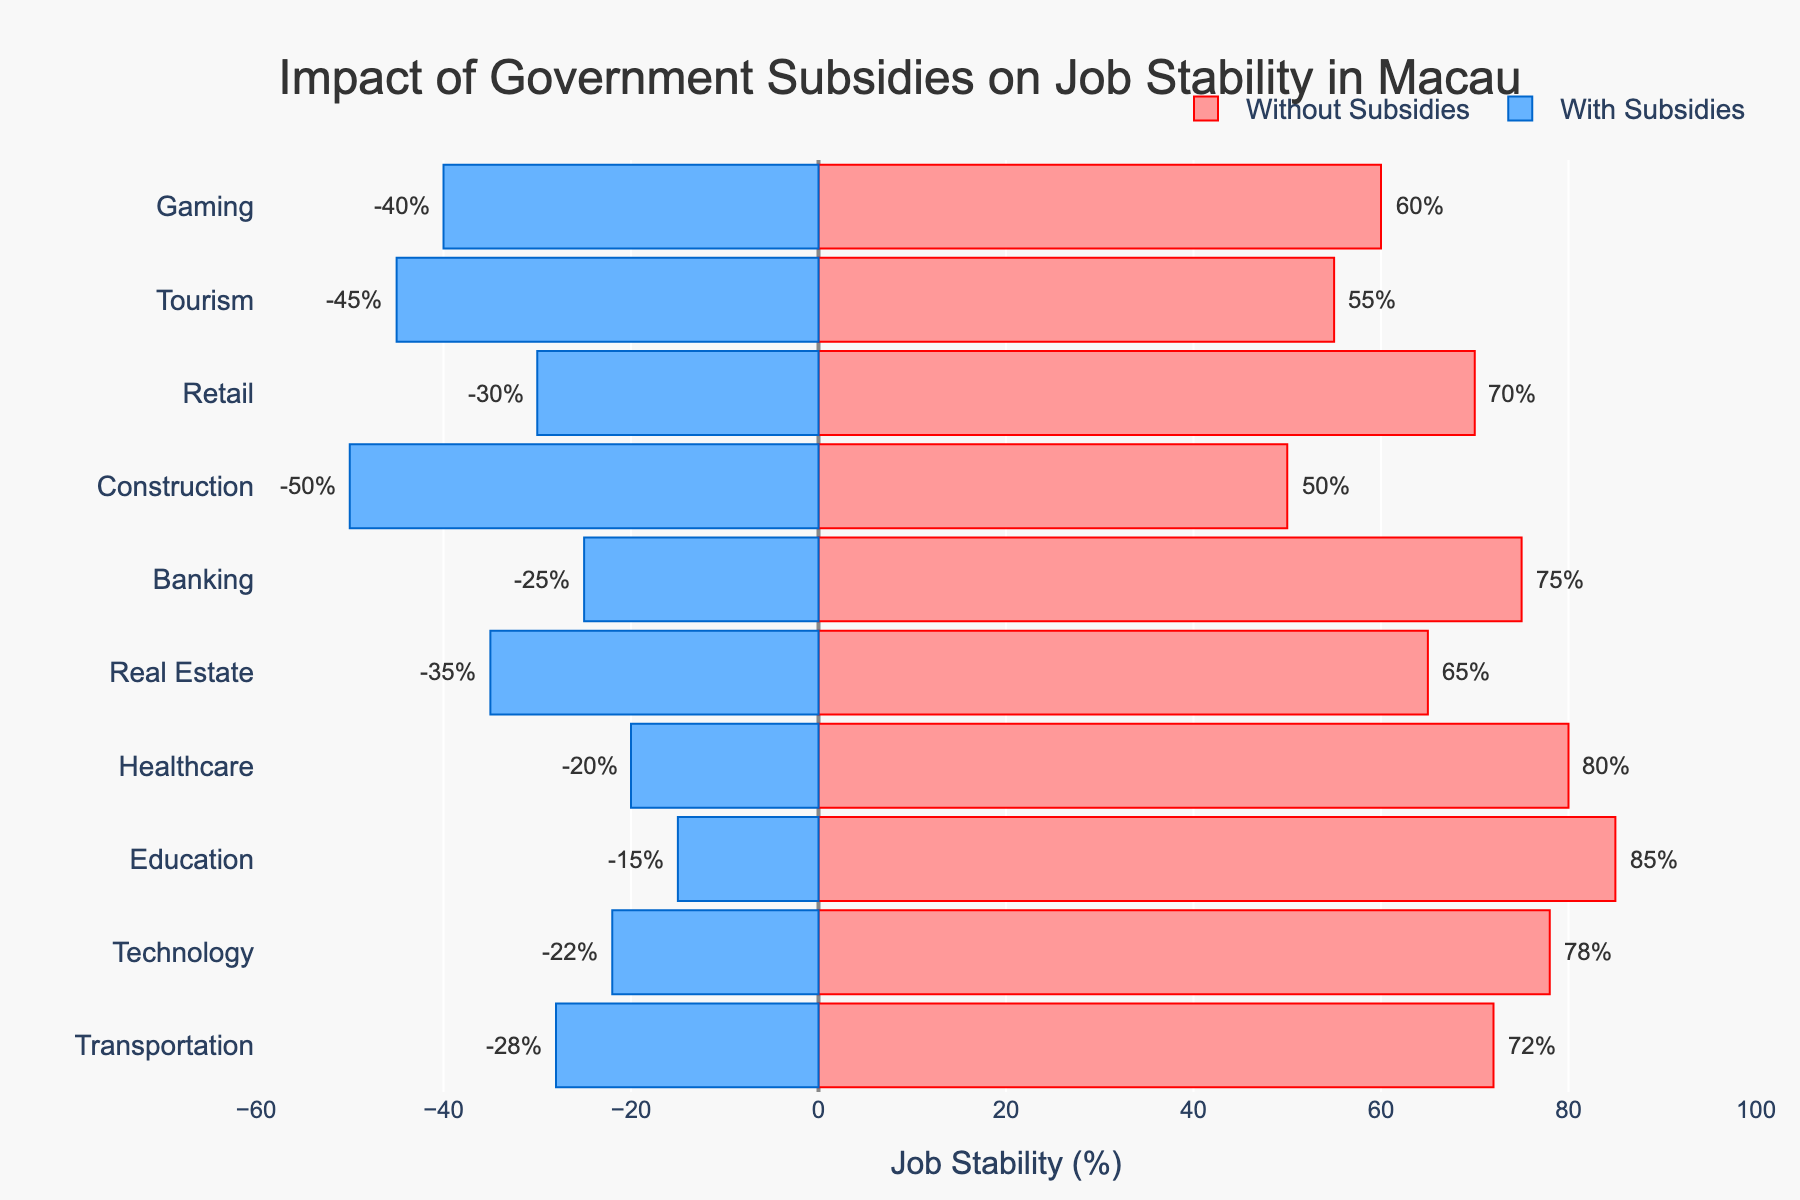Which sector shows the smallest difference between job stability with and without subsidies? Compare the lengths of the bars for each sector by visually checking the difference between job stability with and without subsidies. Education has the smallest difference at 15% (85% without subsidies and -15% with subsidies).
Answer: Education Which sector has the highest job stability without subsidies? Look at the bars representing job stability without subsidies and identify the longest bar which corresponds to the highest value. The Education sector has the highest job stability without subsidies at 85%.
Answer: Education What is the total job stability (sum of absolute values with and without subsidies) for the Healthcare sector? For Healthcare, add the absolute values of job stability without subsidies (80%) and with subsidies (20%). 80 + 20 = 100.
Answer: 100 How much greater is job stability in the Banking sector without subsidies compared to with subsidies? Subtract job stability with subsidies (25%) from job stability without subsidies (75%) for the Banking sector. 75 - 25 = 50.
Answer: 50 Which sector experiences the most significant decrease in job stability when subsidies are applied? Identify the sector with the largest absolute difference between job stability without and with subsidies. The Construction sector has the largest decrease from 50% without subsidies to -50% with subsidies, which is a 100% change.
Answer: Construction What is the median job stability without subsidies across all sectors? List the job stability percentages without subsidies: 50, 55, 60, 65, 70, 72, 75, 78, 80, 85. The median is the middle value of the sorted list, which is (70 + 72) / 2 = 71.
Answer: 71 Is job stability without subsidies for the Real Estate sector higher, lower, or equal to the Technology sector? Compare the job stability without subsidies for Real Estate (65%) and Technology (78%). Real Estate's 65% is lower than Technology's 78%.
Answer: Lower Which sector has the highest job stability with subsidies? Look at the bars representing job stability with subsidies and identify the longest (least negative) bar. The Education sector has the highest job stability with subsidies at -15%.
Answer: Education For which sectors is job stability higher without subsidies than with subsidies? Compare each sector's job stability without and with subsidies. All sectors have higher job stability without subsidies.
Answer: All sectors What is the average job stability with subsidies across all sectors? List the job stability percentages with subsidies: -40, -45, -30, -50, -25, -35, -20, -15, -22, -28. Calculate the average: (-40 - 45 - 30 - 50 - 25 - 35 - 20 - 15 - 22 - 28) / 10 = -31.
Answer: -31 